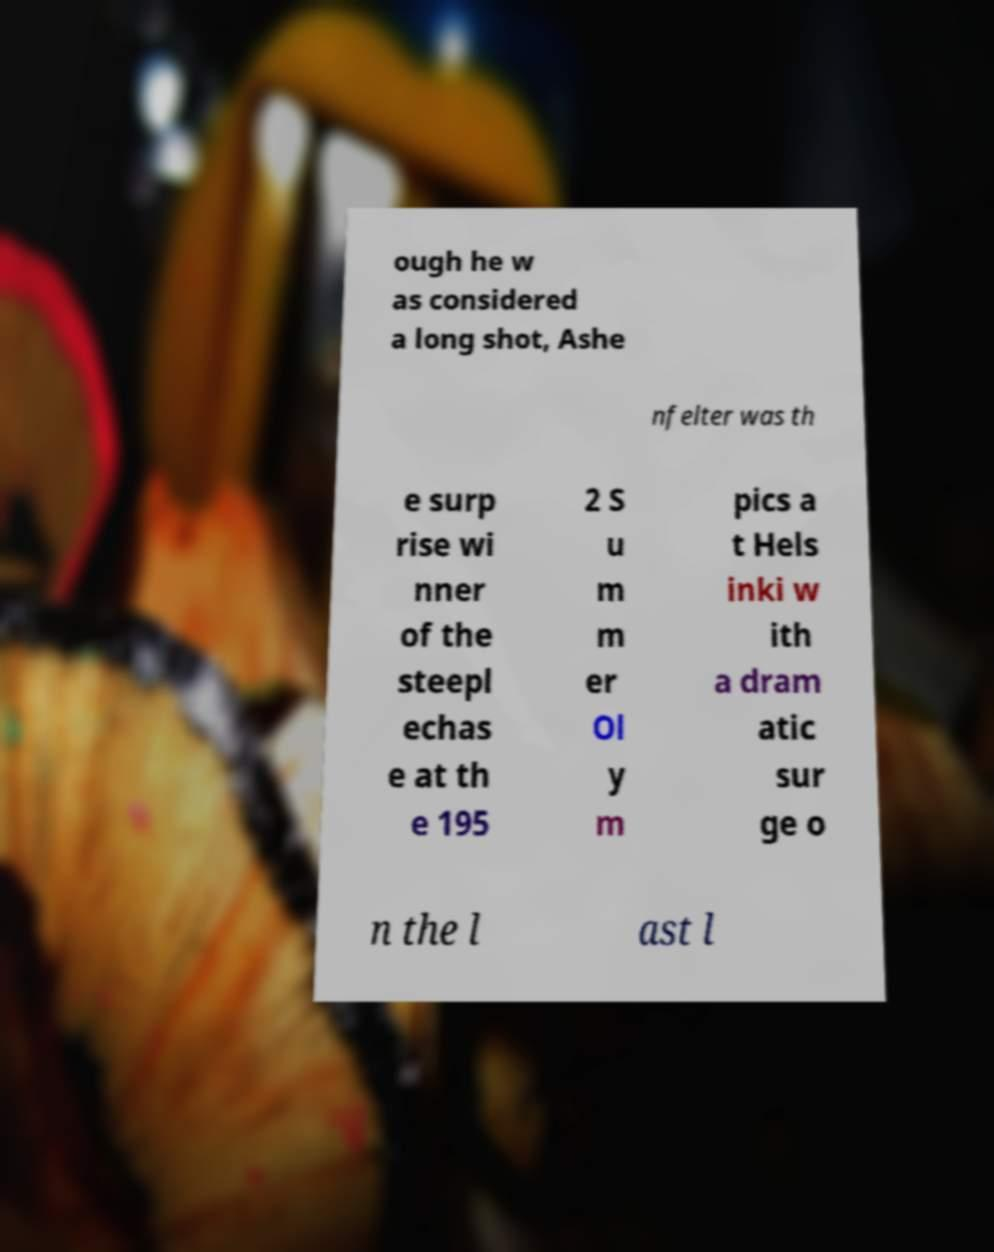There's text embedded in this image that I need extracted. Can you transcribe it verbatim? ough he w as considered a long shot, Ashe nfelter was th e surp rise wi nner of the steepl echas e at th e 195 2 S u m m er Ol y m pics a t Hels inki w ith a dram atic sur ge o n the l ast l 